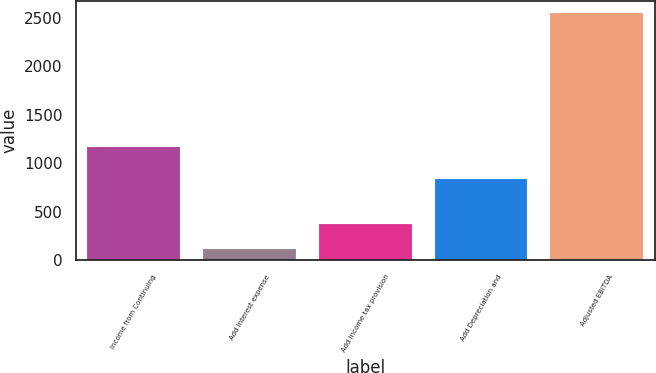Convert chart to OTSL. <chart><loc_0><loc_0><loc_500><loc_500><bar_chart><fcel>Income from Continuing<fcel>Add Interest expense<fcel>Add Income tax provision<fcel>Add Depreciation and<fcel>Adjusted EBITDA<nl><fcel>1171.6<fcel>115.5<fcel>375.3<fcel>834.3<fcel>2545.2<nl></chart> 